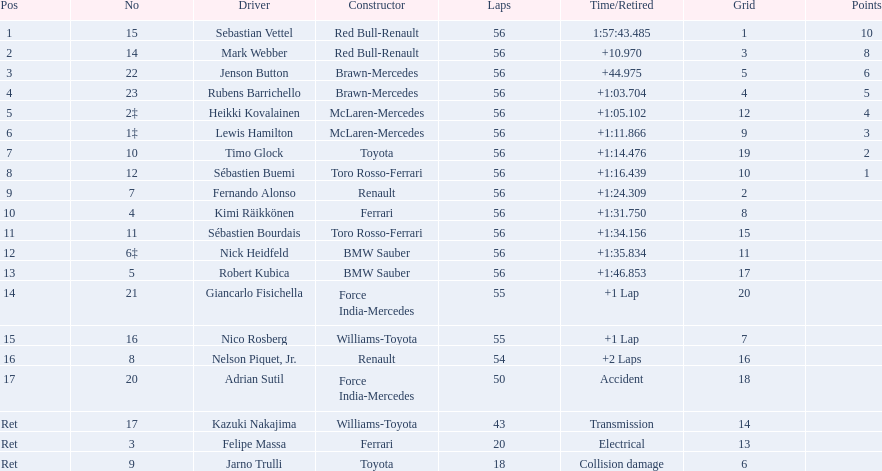Who were the drivers at the 2009 chinese grand prix? Sebastian Vettel, Mark Webber, Jenson Button, Rubens Barrichello, Heikki Kovalainen, Lewis Hamilton, Timo Glock, Sébastien Buemi, Fernando Alonso, Kimi Räikkönen, Sébastien Bourdais, Nick Heidfeld, Robert Kubica, Giancarlo Fisichella, Nico Rosberg, Nelson Piquet, Jr., Adrian Sutil, Kazuki Nakajima, Felipe Massa, Jarno Trulli. Who had the slowest time? Robert Kubica. 